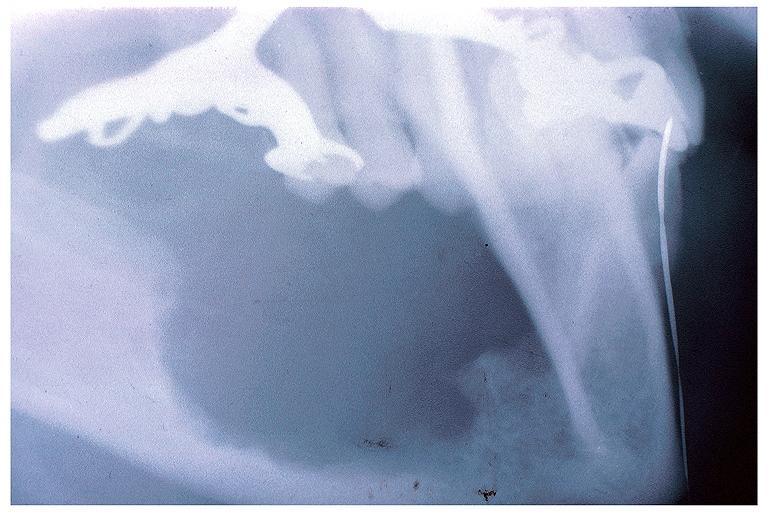where is this?
Answer the question using a single word or phrase. Oral 